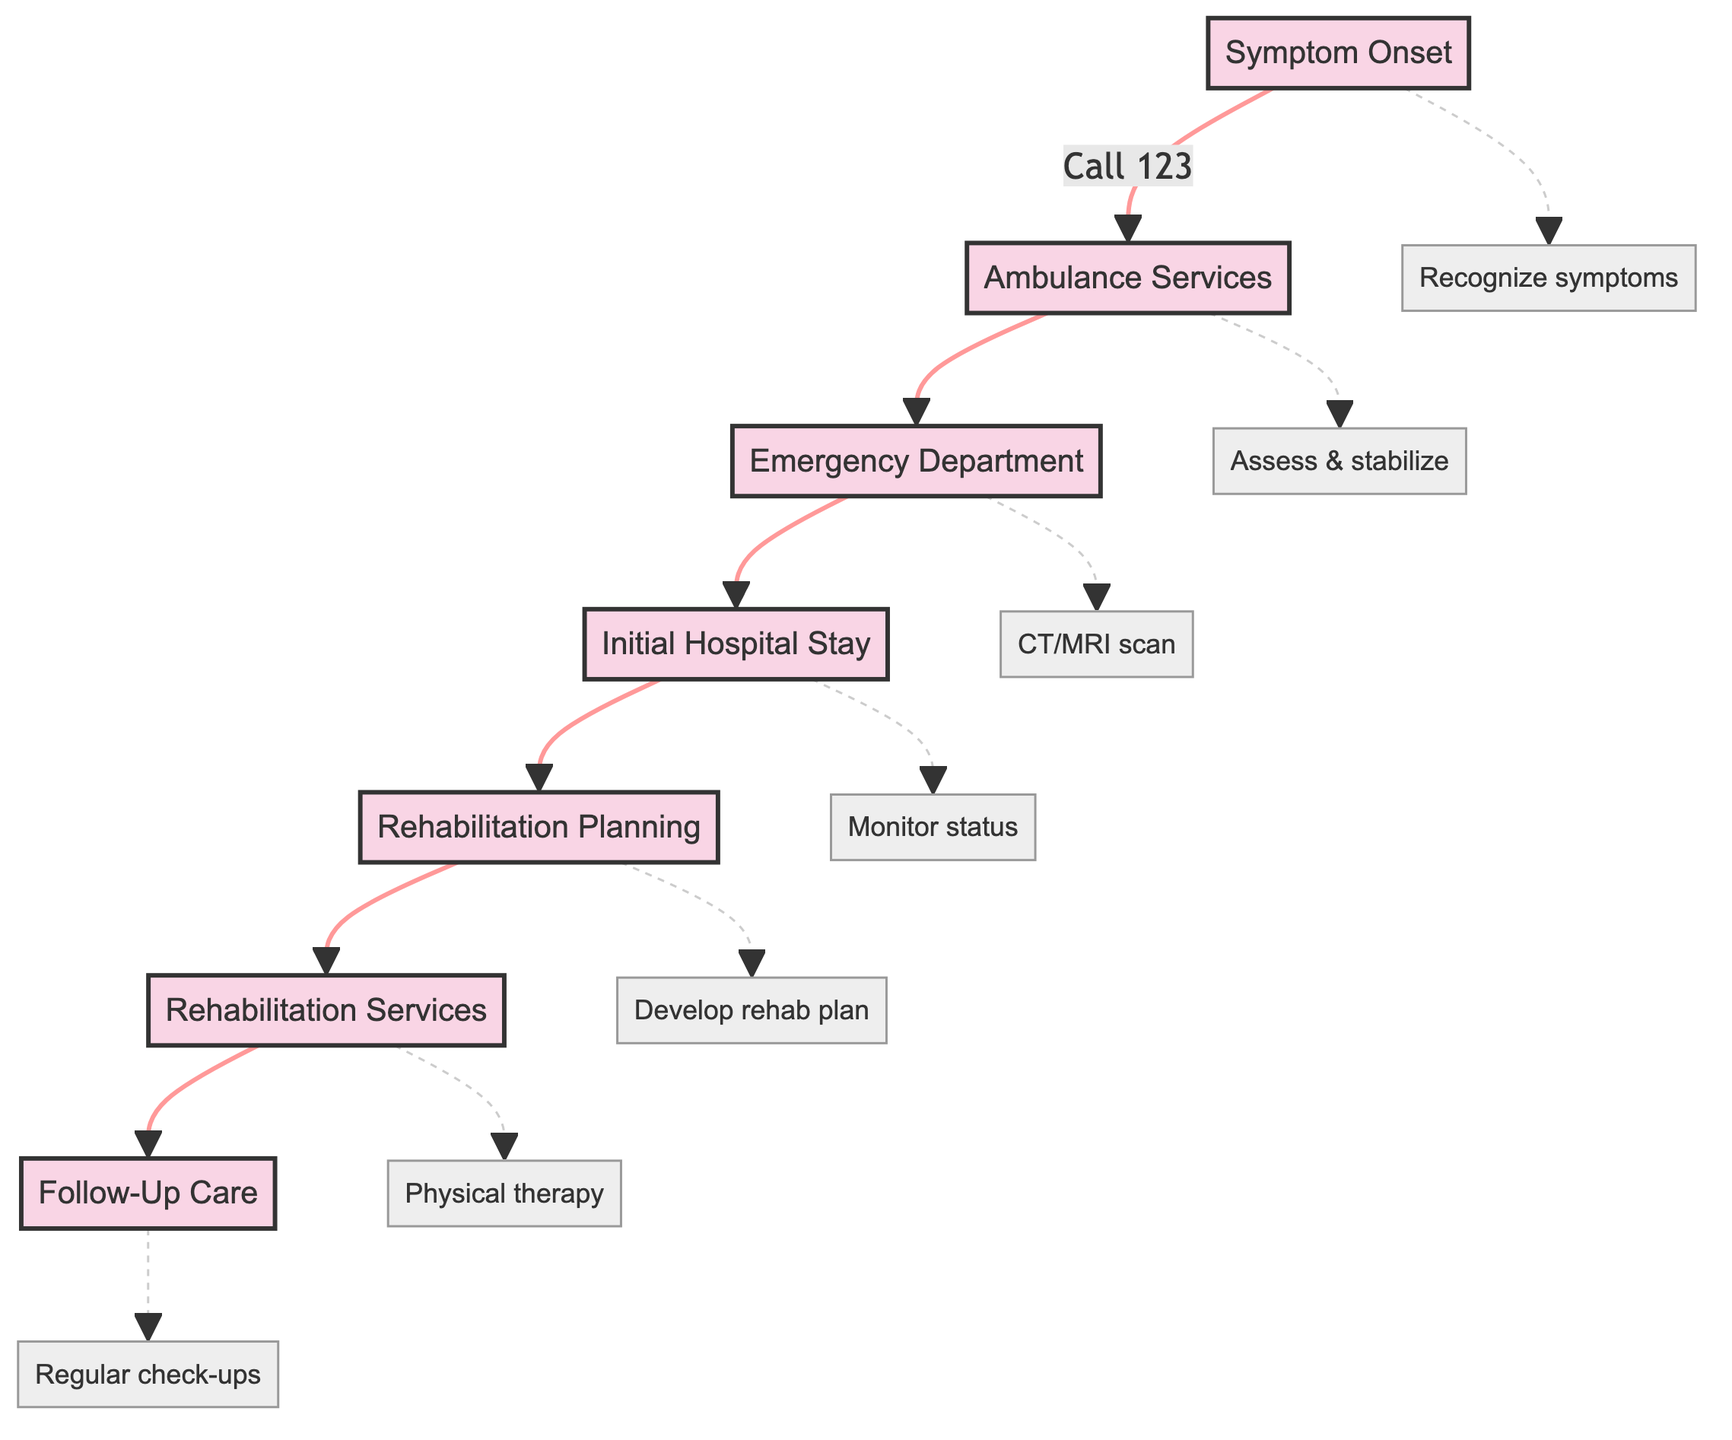What is the first step in the clinical pathway? The first step is "Symptom Onset," where the patient experiences sudden symptoms.
Answer: Symptom Onset How many main steps are there in the clinical pathway? There are seven main steps outlined in the diagram.
Answer: Seven What action is taken during the "Emergency Department" step? The key action is to perform a "CT/MRI scan" to confirm the stroke type.
Answer: CT/MRI scan Which step involves a multidisciplinary team? The "Rehabilitation Planning" step involves a multidisciplinary team for assessment.
Answer: Rehabilitation Planning What are the two key actions performed in the "Rehabilitation Services" step? The key actions are "Physical therapy" and "Occupational therapy."
Answer: Physical therapy and Occupational therapy How does the "Follow-Up Care" connect to the previous step? "Follow-Up Care" connects from "Rehabilitation Services," indicating ongoing care after rehabilitation.
Answer: Rehabilitation Services What is the last action taken in the pathway? The last action is "Regular check-ups" to ensure ongoing health after rehabilitation.
Answer: Regular check-ups What immediate recognition is required at the "Symptom Onset"? There is a need for immediate recognition of "stroke symptoms" at this step.
Answer: Stroke symptoms What type of therapy is provided if needed during the rehabilitation phase? "Speech and language therapy" is provided if necessary during rehabilitation services.
Answer: Speech and language therapy 